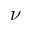<formula> <loc_0><loc_0><loc_500><loc_500>\nu</formula> 